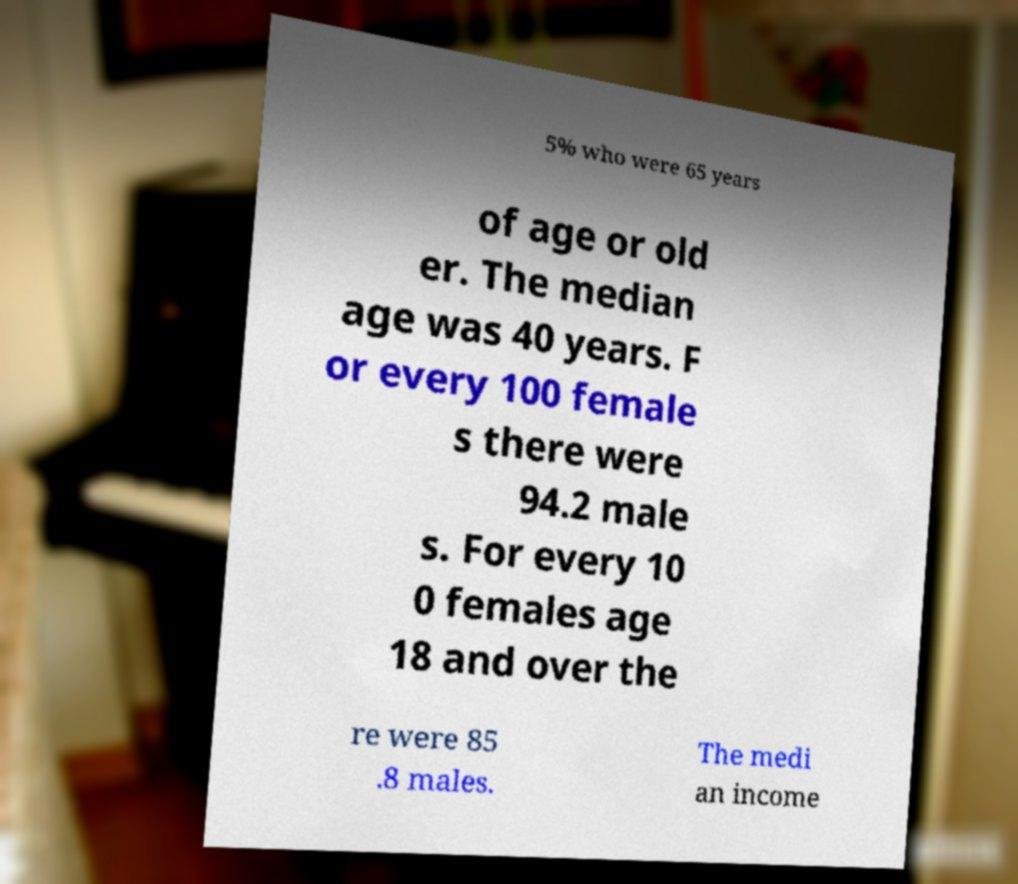Can you read and provide the text displayed in the image?This photo seems to have some interesting text. Can you extract and type it out for me? 5% who were 65 years of age or old er. The median age was 40 years. F or every 100 female s there were 94.2 male s. For every 10 0 females age 18 and over the re were 85 .8 males. The medi an income 